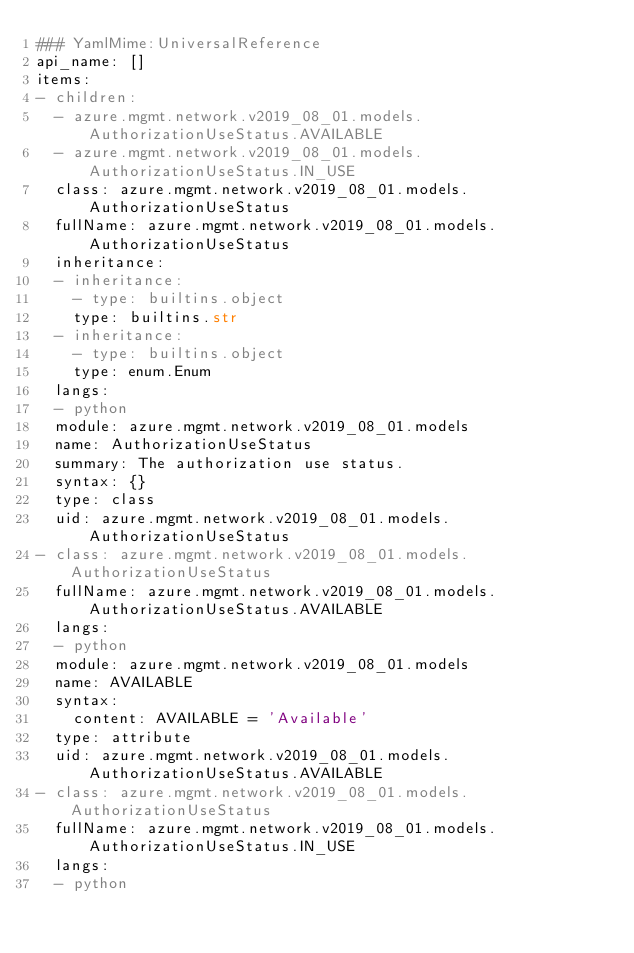Convert code to text. <code><loc_0><loc_0><loc_500><loc_500><_YAML_>### YamlMime:UniversalReference
api_name: []
items:
- children:
  - azure.mgmt.network.v2019_08_01.models.AuthorizationUseStatus.AVAILABLE
  - azure.mgmt.network.v2019_08_01.models.AuthorizationUseStatus.IN_USE
  class: azure.mgmt.network.v2019_08_01.models.AuthorizationUseStatus
  fullName: azure.mgmt.network.v2019_08_01.models.AuthorizationUseStatus
  inheritance:
  - inheritance:
    - type: builtins.object
    type: builtins.str
  - inheritance:
    - type: builtins.object
    type: enum.Enum
  langs:
  - python
  module: azure.mgmt.network.v2019_08_01.models
  name: AuthorizationUseStatus
  summary: The authorization use status.
  syntax: {}
  type: class
  uid: azure.mgmt.network.v2019_08_01.models.AuthorizationUseStatus
- class: azure.mgmt.network.v2019_08_01.models.AuthorizationUseStatus
  fullName: azure.mgmt.network.v2019_08_01.models.AuthorizationUseStatus.AVAILABLE
  langs:
  - python
  module: azure.mgmt.network.v2019_08_01.models
  name: AVAILABLE
  syntax:
    content: AVAILABLE = 'Available'
  type: attribute
  uid: azure.mgmt.network.v2019_08_01.models.AuthorizationUseStatus.AVAILABLE
- class: azure.mgmt.network.v2019_08_01.models.AuthorizationUseStatus
  fullName: azure.mgmt.network.v2019_08_01.models.AuthorizationUseStatus.IN_USE
  langs:
  - python</code> 